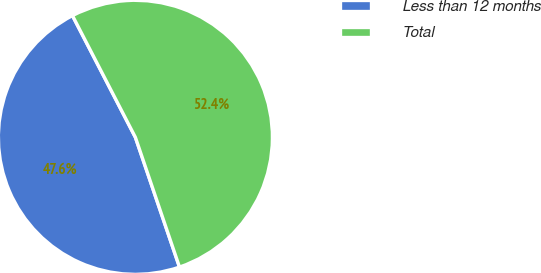<chart> <loc_0><loc_0><loc_500><loc_500><pie_chart><fcel>Less than 12 months<fcel>Total<nl><fcel>47.62%<fcel>52.38%<nl></chart> 